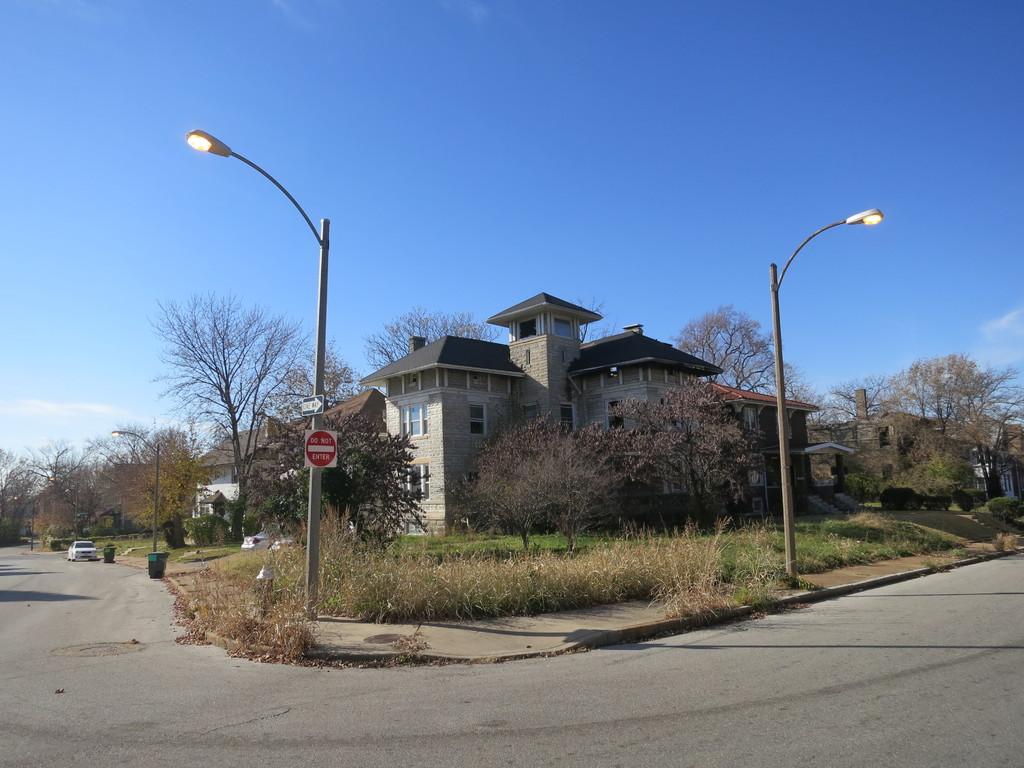What did the red sign telling us to not do?
Your response must be concise. Do not enter. 